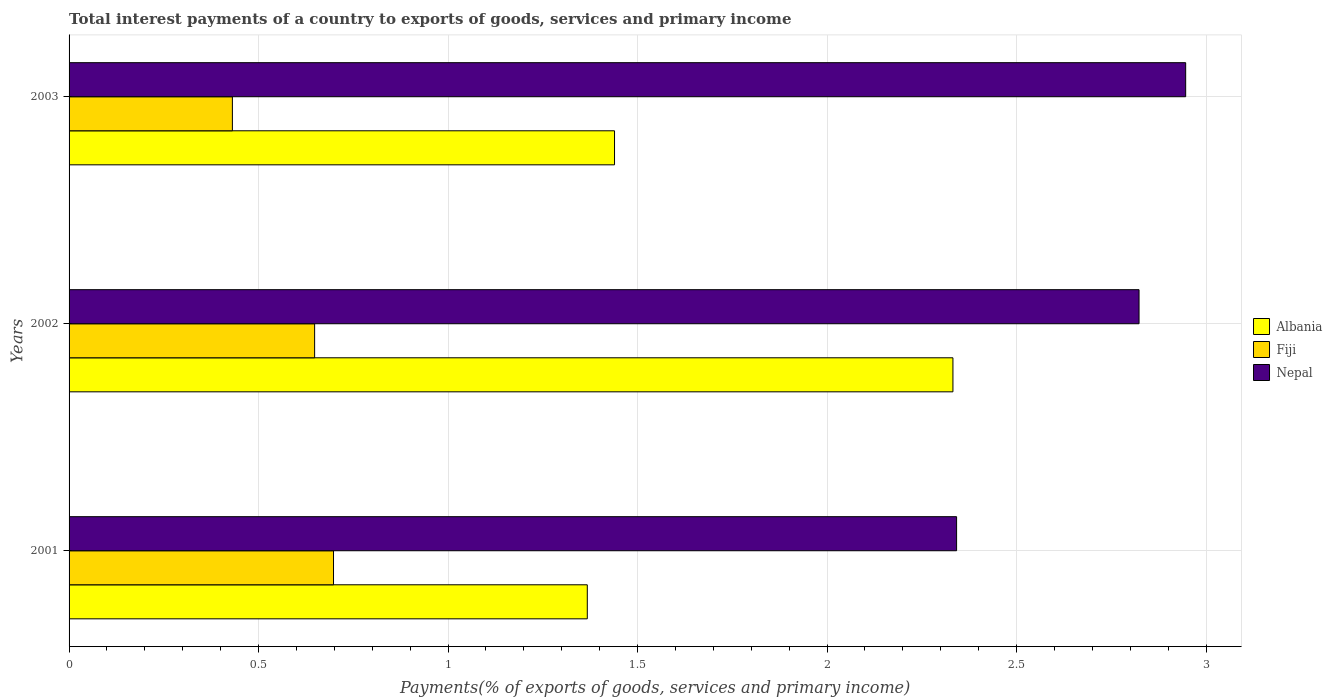How many groups of bars are there?
Provide a short and direct response. 3. What is the label of the 3rd group of bars from the top?
Give a very brief answer. 2001. What is the total interest payments in Albania in 2001?
Your response must be concise. 1.37. Across all years, what is the maximum total interest payments in Nepal?
Keep it short and to the point. 2.95. Across all years, what is the minimum total interest payments in Nepal?
Provide a succinct answer. 2.34. In which year was the total interest payments in Albania maximum?
Your answer should be compact. 2002. What is the total total interest payments in Fiji in the graph?
Give a very brief answer. 1.78. What is the difference between the total interest payments in Fiji in 2002 and that in 2003?
Your response must be concise. 0.22. What is the difference between the total interest payments in Albania in 2003 and the total interest payments in Nepal in 2002?
Provide a short and direct response. -1.38. What is the average total interest payments in Fiji per year?
Make the answer very short. 0.59. In the year 2003, what is the difference between the total interest payments in Nepal and total interest payments in Albania?
Keep it short and to the point. 1.51. In how many years, is the total interest payments in Fiji greater than 1.1 %?
Keep it short and to the point. 0. What is the ratio of the total interest payments in Albania in 2001 to that in 2003?
Provide a succinct answer. 0.95. Is the total interest payments in Fiji in 2002 less than that in 2003?
Ensure brevity in your answer.  No. Is the difference between the total interest payments in Nepal in 2001 and 2003 greater than the difference between the total interest payments in Albania in 2001 and 2003?
Ensure brevity in your answer.  No. What is the difference between the highest and the second highest total interest payments in Albania?
Provide a succinct answer. 0.89. What is the difference between the highest and the lowest total interest payments in Nepal?
Give a very brief answer. 0.6. What does the 1st bar from the top in 2001 represents?
Your answer should be very brief. Nepal. What does the 2nd bar from the bottom in 2002 represents?
Offer a terse response. Fiji. Is it the case that in every year, the sum of the total interest payments in Albania and total interest payments in Nepal is greater than the total interest payments in Fiji?
Ensure brevity in your answer.  Yes. How many bars are there?
Give a very brief answer. 9. Does the graph contain grids?
Offer a very short reply. Yes. How are the legend labels stacked?
Make the answer very short. Vertical. What is the title of the graph?
Provide a succinct answer. Total interest payments of a country to exports of goods, services and primary income. Does "Middle East & North Africa (developing only)" appear as one of the legend labels in the graph?
Provide a succinct answer. No. What is the label or title of the X-axis?
Offer a terse response. Payments(% of exports of goods, services and primary income). What is the label or title of the Y-axis?
Make the answer very short. Years. What is the Payments(% of exports of goods, services and primary income) of Albania in 2001?
Give a very brief answer. 1.37. What is the Payments(% of exports of goods, services and primary income) in Fiji in 2001?
Ensure brevity in your answer.  0.7. What is the Payments(% of exports of goods, services and primary income) in Nepal in 2001?
Your answer should be compact. 2.34. What is the Payments(% of exports of goods, services and primary income) of Albania in 2002?
Your answer should be very brief. 2.33. What is the Payments(% of exports of goods, services and primary income) in Fiji in 2002?
Make the answer very short. 0.65. What is the Payments(% of exports of goods, services and primary income) in Nepal in 2002?
Keep it short and to the point. 2.82. What is the Payments(% of exports of goods, services and primary income) of Albania in 2003?
Ensure brevity in your answer.  1.44. What is the Payments(% of exports of goods, services and primary income) in Fiji in 2003?
Give a very brief answer. 0.43. What is the Payments(% of exports of goods, services and primary income) of Nepal in 2003?
Keep it short and to the point. 2.95. Across all years, what is the maximum Payments(% of exports of goods, services and primary income) of Albania?
Provide a short and direct response. 2.33. Across all years, what is the maximum Payments(% of exports of goods, services and primary income) of Fiji?
Your response must be concise. 0.7. Across all years, what is the maximum Payments(% of exports of goods, services and primary income) in Nepal?
Your answer should be very brief. 2.95. Across all years, what is the minimum Payments(% of exports of goods, services and primary income) in Albania?
Your answer should be compact. 1.37. Across all years, what is the minimum Payments(% of exports of goods, services and primary income) in Fiji?
Ensure brevity in your answer.  0.43. Across all years, what is the minimum Payments(% of exports of goods, services and primary income) in Nepal?
Provide a succinct answer. 2.34. What is the total Payments(% of exports of goods, services and primary income) in Albania in the graph?
Offer a terse response. 5.14. What is the total Payments(% of exports of goods, services and primary income) in Fiji in the graph?
Your answer should be compact. 1.78. What is the total Payments(% of exports of goods, services and primary income) of Nepal in the graph?
Your answer should be compact. 8.11. What is the difference between the Payments(% of exports of goods, services and primary income) in Albania in 2001 and that in 2002?
Give a very brief answer. -0.96. What is the difference between the Payments(% of exports of goods, services and primary income) of Fiji in 2001 and that in 2002?
Give a very brief answer. 0.05. What is the difference between the Payments(% of exports of goods, services and primary income) in Nepal in 2001 and that in 2002?
Your answer should be compact. -0.48. What is the difference between the Payments(% of exports of goods, services and primary income) in Albania in 2001 and that in 2003?
Give a very brief answer. -0.07. What is the difference between the Payments(% of exports of goods, services and primary income) of Fiji in 2001 and that in 2003?
Keep it short and to the point. 0.27. What is the difference between the Payments(% of exports of goods, services and primary income) in Nepal in 2001 and that in 2003?
Your response must be concise. -0.6. What is the difference between the Payments(% of exports of goods, services and primary income) in Albania in 2002 and that in 2003?
Make the answer very short. 0.89. What is the difference between the Payments(% of exports of goods, services and primary income) of Fiji in 2002 and that in 2003?
Provide a succinct answer. 0.22. What is the difference between the Payments(% of exports of goods, services and primary income) of Nepal in 2002 and that in 2003?
Provide a succinct answer. -0.12. What is the difference between the Payments(% of exports of goods, services and primary income) in Albania in 2001 and the Payments(% of exports of goods, services and primary income) in Fiji in 2002?
Give a very brief answer. 0.72. What is the difference between the Payments(% of exports of goods, services and primary income) in Albania in 2001 and the Payments(% of exports of goods, services and primary income) in Nepal in 2002?
Ensure brevity in your answer.  -1.46. What is the difference between the Payments(% of exports of goods, services and primary income) in Fiji in 2001 and the Payments(% of exports of goods, services and primary income) in Nepal in 2002?
Offer a terse response. -2.13. What is the difference between the Payments(% of exports of goods, services and primary income) of Albania in 2001 and the Payments(% of exports of goods, services and primary income) of Fiji in 2003?
Give a very brief answer. 0.94. What is the difference between the Payments(% of exports of goods, services and primary income) of Albania in 2001 and the Payments(% of exports of goods, services and primary income) of Nepal in 2003?
Make the answer very short. -1.58. What is the difference between the Payments(% of exports of goods, services and primary income) in Fiji in 2001 and the Payments(% of exports of goods, services and primary income) in Nepal in 2003?
Keep it short and to the point. -2.25. What is the difference between the Payments(% of exports of goods, services and primary income) of Albania in 2002 and the Payments(% of exports of goods, services and primary income) of Fiji in 2003?
Offer a terse response. 1.9. What is the difference between the Payments(% of exports of goods, services and primary income) of Albania in 2002 and the Payments(% of exports of goods, services and primary income) of Nepal in 2003?
Provide a succinct answer. -0.61. What is the difference between the Payments(% of exports of goods, services and primary income) of Fiji in 2002 and the Payments(% of exports of goods, services and primary income) of Nepal in 2003?
Provide a short and direct response. -2.3. What is the average Payments(% of exports of goods, services and primary income) in Albania per year?
Your response must be concise. 1.71. What is the average Payments(% of exports of goods, services and primary income) in Fiji per year?
Give a very brief answer. 0.59. What is the average Payments(% of exports of goods, services and primary income) in Nepal per year?
Your response must be concise. 2.7. In the year 2001, what is the difference between the Payments(% of exports of goods, services and primary income) in Albania and Payments(% of exports of goods, services and primary income) in Fiji?
Ensure brevity in your answer.  0.67. In the year 2001, what is the difference between the Payments(% of exports of goods, services and primary income) of Albania and Payments(% of exports of goods, services and primary income) of Nepal?
Provide a succinct answer. -0.97. In the year 2001, what is the difference between the Payments(% of exports of goods, services and primary income) in Fiji and Payments(% of exports of goods, services and primary income) in Nepal?
Your response must be concise. -1.64. In the year 2002, what is the difference between the Payments(% of exports of goods, services and primary income) in Albania and Payments(% of exports of goods, services and primary income) in Fiji?
Keep it short and to the point. 1.68. In the year 2002, what is the difference between the Payments(% of exports of goods, services and primary income) of Albania and Payments(% of exports of goods, services and primary income) of Nepal?
Give a very brief answer. -0.49. In the year 2002, what is the difference between the Payments(% of exports of goods, services and primary income) of Fiji and Payments(% of exports of goods, services and primary income) of Nepal?
Your response must be concise. -2.18. In the year 2003, what is the difference between the Payments(% of exports of goods, services and primary income) of Albania and Payments(% of exports of goods, services and primary income) of Fiji?
Your answer should be compact. 1.01. In the year 2003, what is the difference between the Payments(% of exports of goods, services and primary income) of Albania and Payments(% of exports of goods, services and primary income) of Nepal?
Keep it short and to the point. -1.51. In the year 2003, what is the difference between the Payments(% of exports of goods, services and primary income) in Fiji and Payments(% of exports of goods, services and primary income) in Nepal?
Provide a short and direct response. -2.52. What is the ratio of the Payments(% of exports of goods, services and primary income) of Albania in 2001 to that in 2002?
Give a very brief answer. 0.59. What is the ratio of the Payments(% of exports of goods, services and primary income) of Nepal in 2001 to that in 2002?
Give a very brief answer. 0.83. What is the ratio of the Payments(% of exports of goods, services and primary income) in Fiji in 2001 to that in 2003?
Ensure brevity in your answer.  1.62. What is the ratio of the Payments(% of exports of goods, services and primary income) of Nepal in 2001 to that in 2003?
Make the answer very short. 0.79. What is the ratio of the Payments(% of exports of goods, services and primary income) in Albania in 2002 to that in 2003?
Keep it short and to the point. 1.62. What is the ratio of the Payments(% of exports of goods, services and primary income) in Fiji in 2002 to that in 2003?
Provide a succinct answer. 1.5. What is the ratio of the Payments(% of exports of goods, services and primary income) in Nepal in 2002 to that in 2003?
Provide a short and direct response. 0.96. What is the difference between the highest and the second highest Payments(% of exports of goods, services and primary income) of Albania?
Give a very brief answer. 0.89. What is the difference between the highest and the second highest Payments(% of exports of goods, services and primary income) in Fiji?
Offer a terse response. 0.05. What is the difference between the highest and the second highest Payments(% of exports of goods, services and primary income) in Nepal?
Offer a terse response. 0.12. What is the difference between the highest and the lowest Payments(% of exports of goods, services and primary income) of Albania?
Your response must be concise. 0.96. What is the difference between the highest and the lowest Payments(% of exports of goods, services and primary income) of Fiji?
Provide a succinct answer. 0.27. What is the difference between the highest and the lowest Payments(% of exports of goods, services and primary income) in Nepal?
Your answer should be very brief. 0.6. 